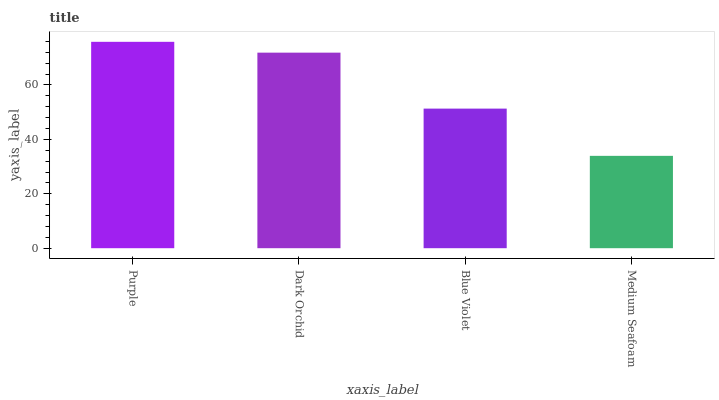Is Medium Seafoam the minimum?
Answer yes or no. Yes. Is Purple the maximum?
Answer yes or no. Yes. Is Dark Orchid the minimum?
Answer yes or no. No. Is Dark Orchid the maximum?
Answer yes or no. No. Is Purple greater than Dark Orchid?
Answer yes or no. Yes. Is Dark Orchid less than Purple?
Answer yes or no. Yes. Is Dark Orchid greater than Purple?
Answer yes or no. No. Is Purple less than Dark Orchid?
Answer yes or no. No. Is Dark Orchid the high median?
Answer yes or no. Yes. Is Blue Violet the low median?
Answer yes or no. Yes. Is Medium Seafoam the high median?
Answer yes or no. No. Is Dark Orchid the low median?
Answer yes or no. No. 